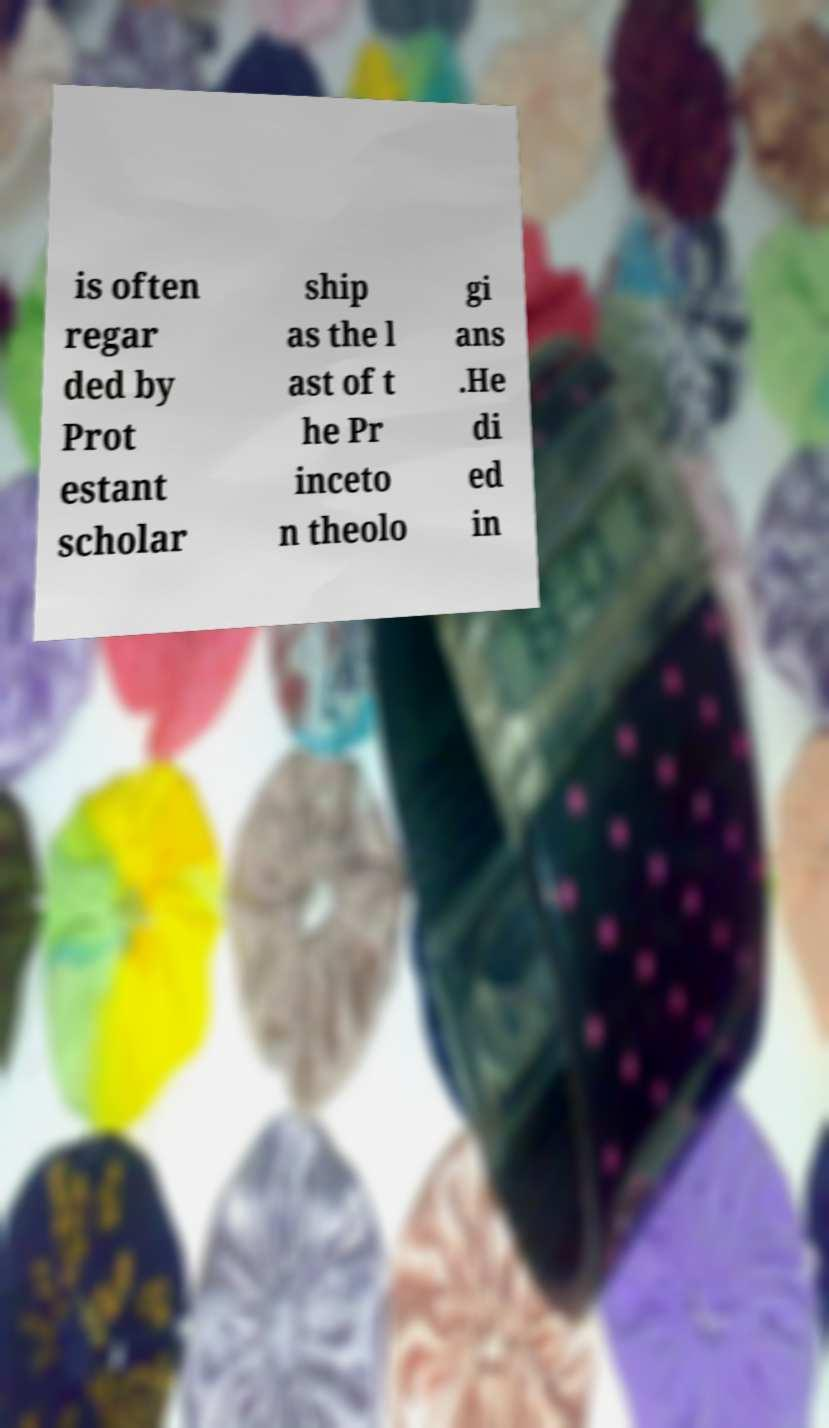Can you read and provide the text displayed in the image?This photo seems to have some interesting text. Can you extract and type it out for me? is often regar ded by Prot estant scholar ship as the l ast of t he Pr inceto n theolo gi ans .He di ed in 